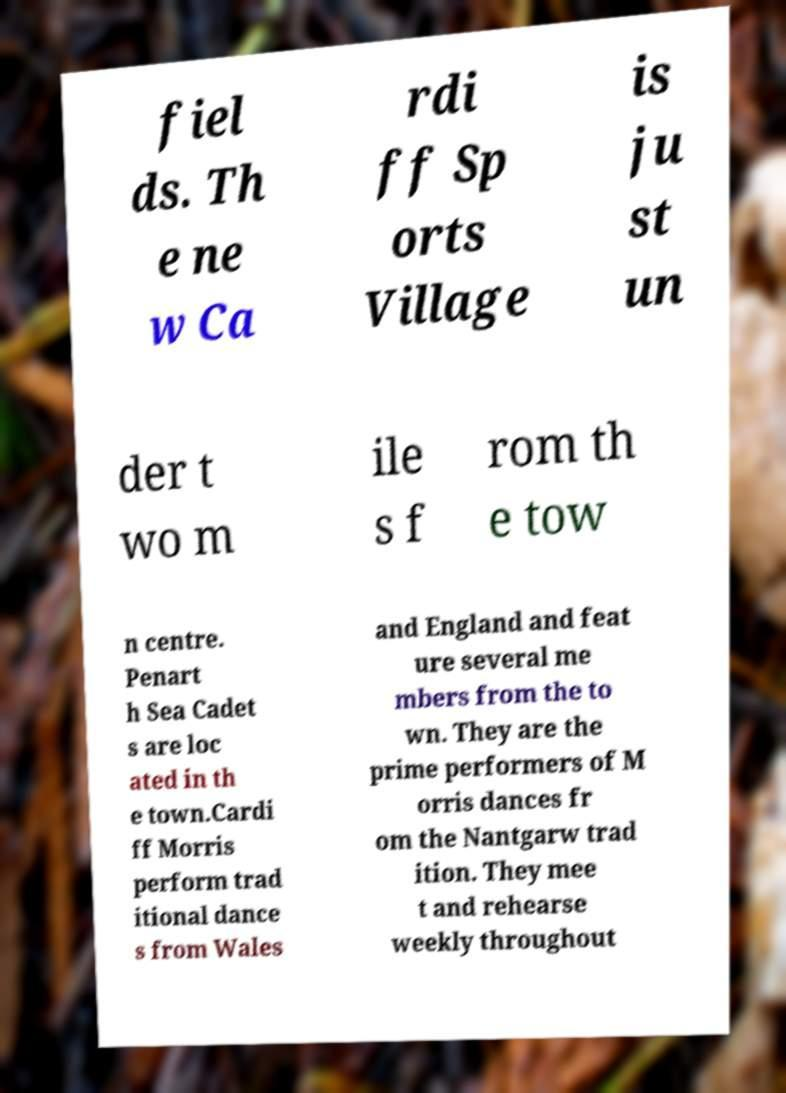Could you extract and type out the text from this image? fiel ds. Th e ne w Ca rdi ff Sp orts Village is ju st un der t wo m ile s f rom th e tow n centre. Penart h Sea Cadet s are loc ated in th e town.Cardi ff Morris perform trad itional dance s from Wales and England and feat ure several me mbers from the to wn. They are the prime performers of M orris dances fr om the Nantgarw trad ition. They mee t and rehearse weekly throughout 